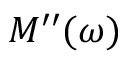Convert formula to latex. <formula><loc_0><loc_0><loc_500><loc_500>M ^ { \prime \prime } ( \omega )</formula> 